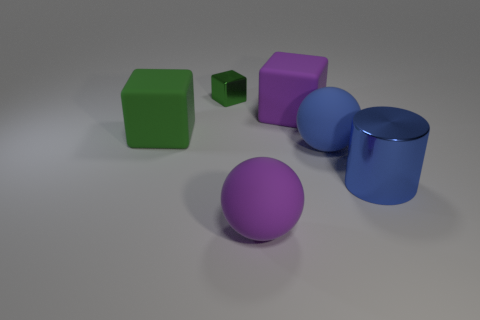Subtract all purple matte cubes. How many cubes are left? 2 Add 4 small blue matte spheres. How many objects exist? 10 Subtract all yellow spheres. How many green blocks are left? 2 Subtract all purple blocks. How many blocks are left? 2 Subtract 1 cylinders. How many cylinders are left? 0 Subtract all cyan balls. Subtract all gray blocks. How many balls are left? 2 Subtract all large green matte objects. Subtract all green metallic blocks. How many objects are left? 4 Add 3 big blue metal cylinders. How many big blue metal cylinders are left? 4 Add 2 green things. How many green things exist? 4 Subtract 0 brown balls. How many objects are left? 6 